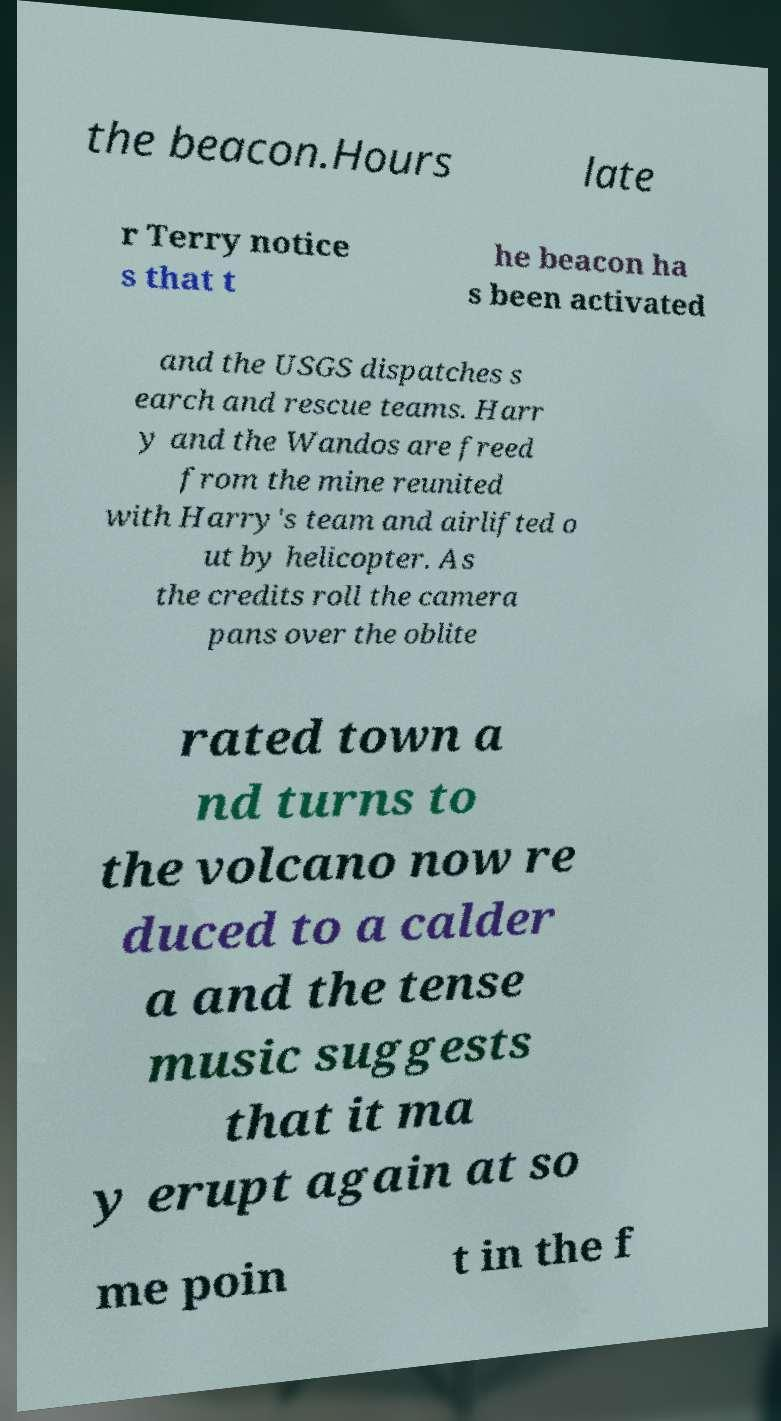Could you extract and type out the text from this image? the beacon.Hours late r Terry notice s that t he beacon ha s been activated and the USGS dispatches s earch and rescue teams. Harr y and the Wandos are freed from the mine reunited with Harry's team and airlifted o ut by helicopter. As the credits roll the camera pans over the oblite rated town a nd turns to the volcano now re duced to a calder a and the tense music suggests that it ma y erupt again at so me poin t in the f 